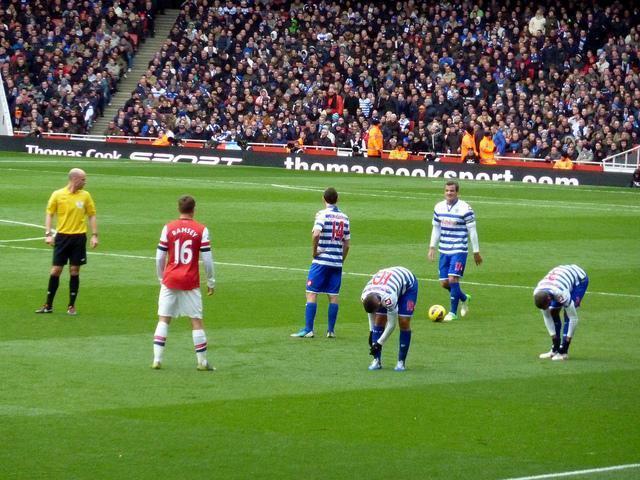How many players are on the field?
Give a very brief answer. 6. How many people are there?
Give a very brief answer. 7. How many red headlights does the train have?
Give a very brief answer. 0. 